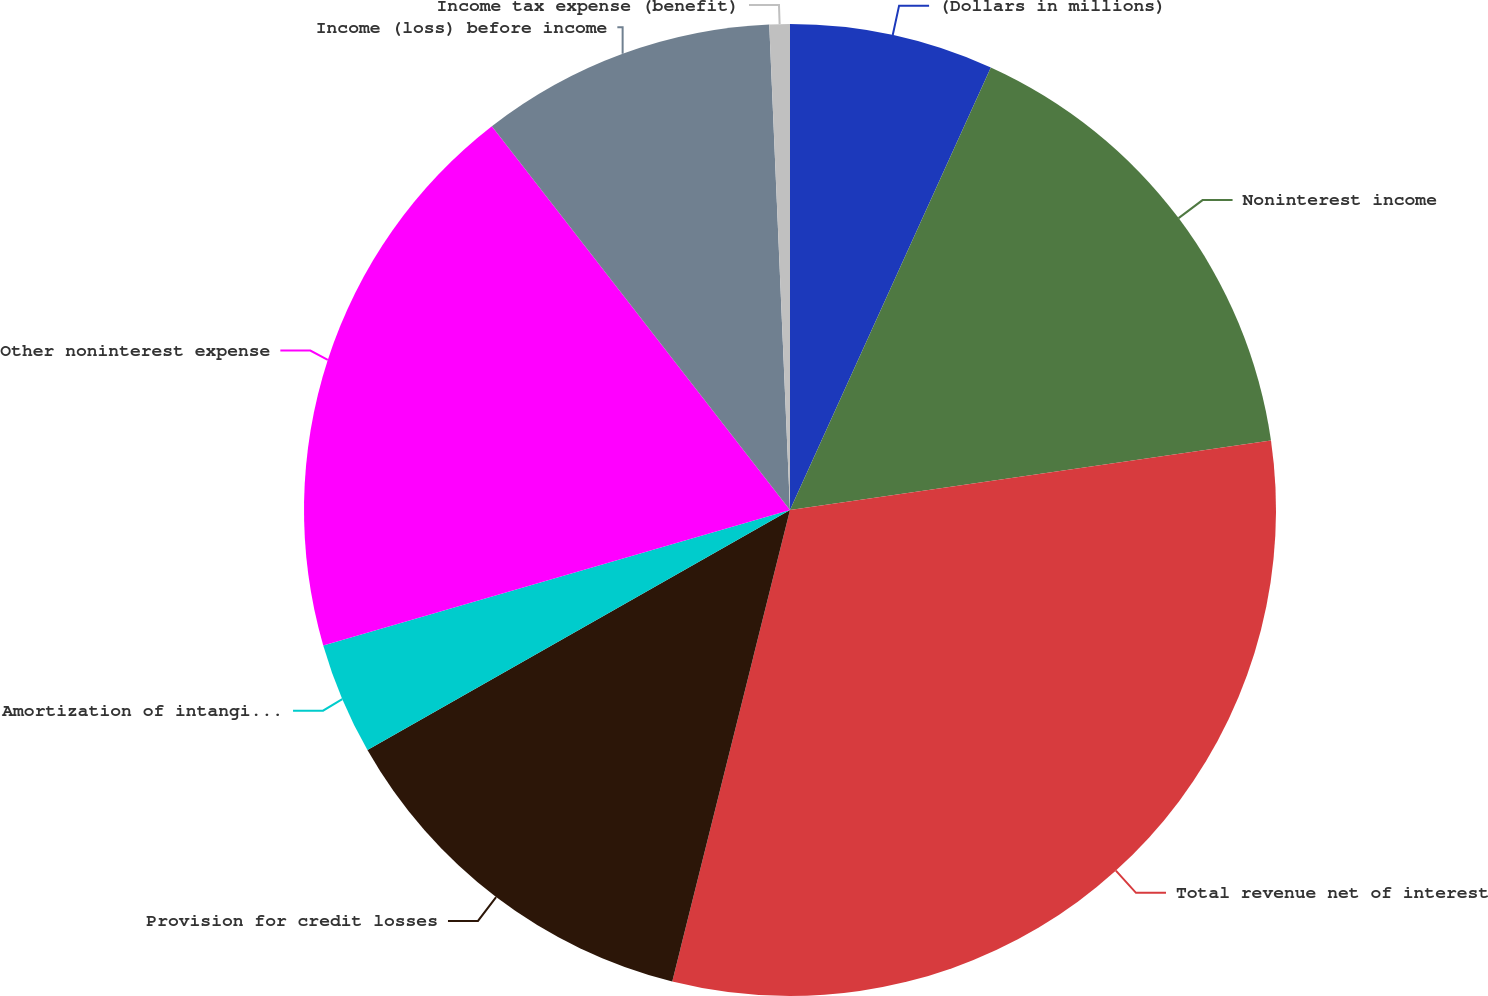Convert chart. <chart><loc_0><loc_0><loc_500><loc_500><pie_chart><fcel>(Dollars in millions)<fcel>Noninterest income<fcel>Total revenue net of interest<fcel>Provision for credit losses<fcel>Amortization of intangibles<fcel>Other noninterest expense<fcel>Income (loss) before income<fcel>Income tax expense (benefit)<nl><fcel>6.78%<fcel>15.93%<fcel>31.18%<fcel>12.88%<fcel>3.73%<fcel>18.98%<fcel>9.83%<fcel>0.68%<nl></chart> 